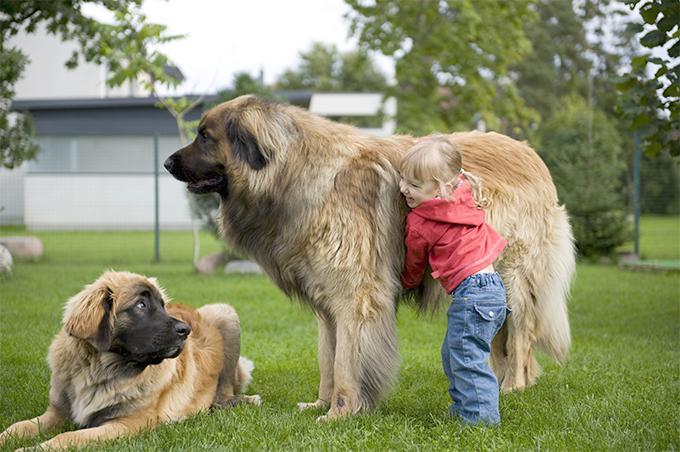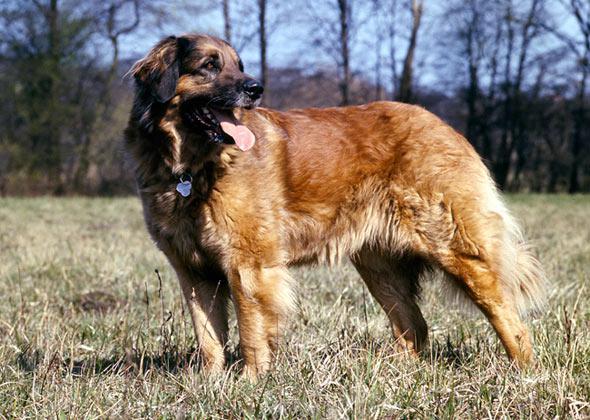The first image is the image on the left, the second image is the image on the right. Examine the images to the left and right. Is the description "One of the dogs is alone in one of the pictures." accurate? Answer yes or no. Yes. 